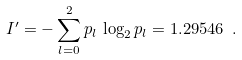Convert formula to latex. <formula><loc_0><loc_0><loc_500><loc_500>I ^ { \prime } = - \sum _ { l = 0 } ^ { 2 } p _ { l } \, \log _ { 2 } p _ { l } = 1 . 2 9 5 4 6 \ .</formula> 